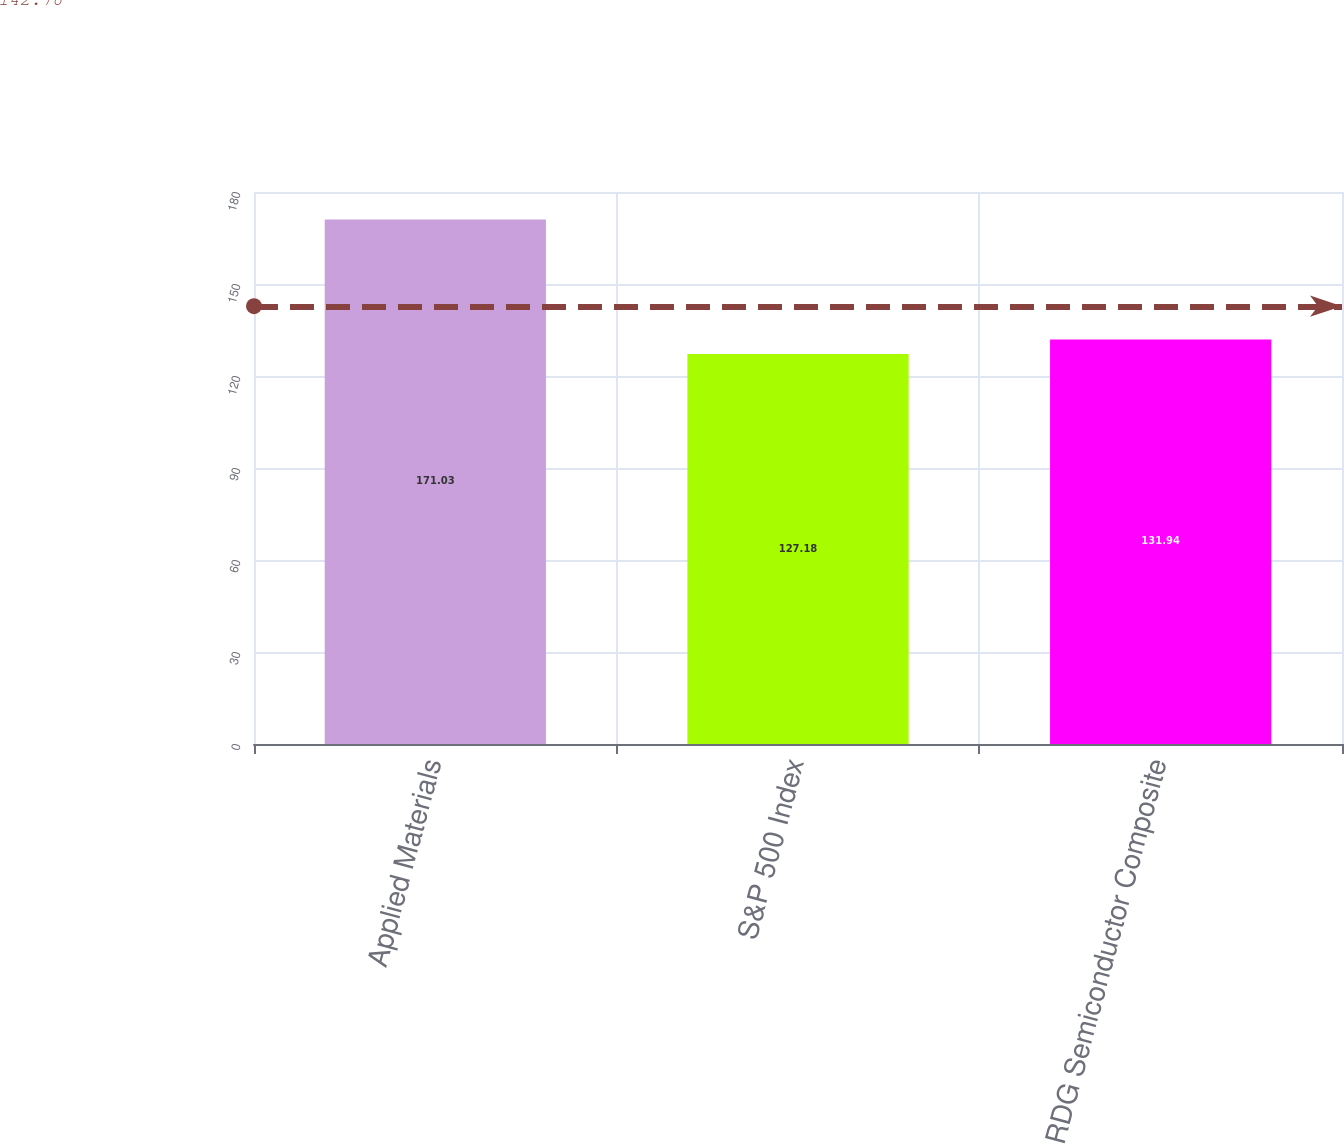<chart> <loc_0><loc_0><loc_500><loc_500><bar_chart><fcel>Applied Materials<fcel>S&P 500 Index<fcel>RDG Semiconductor Composite<nl><fcel>171.03<fcel>127.18<fcel>131.94<nl></chart> 